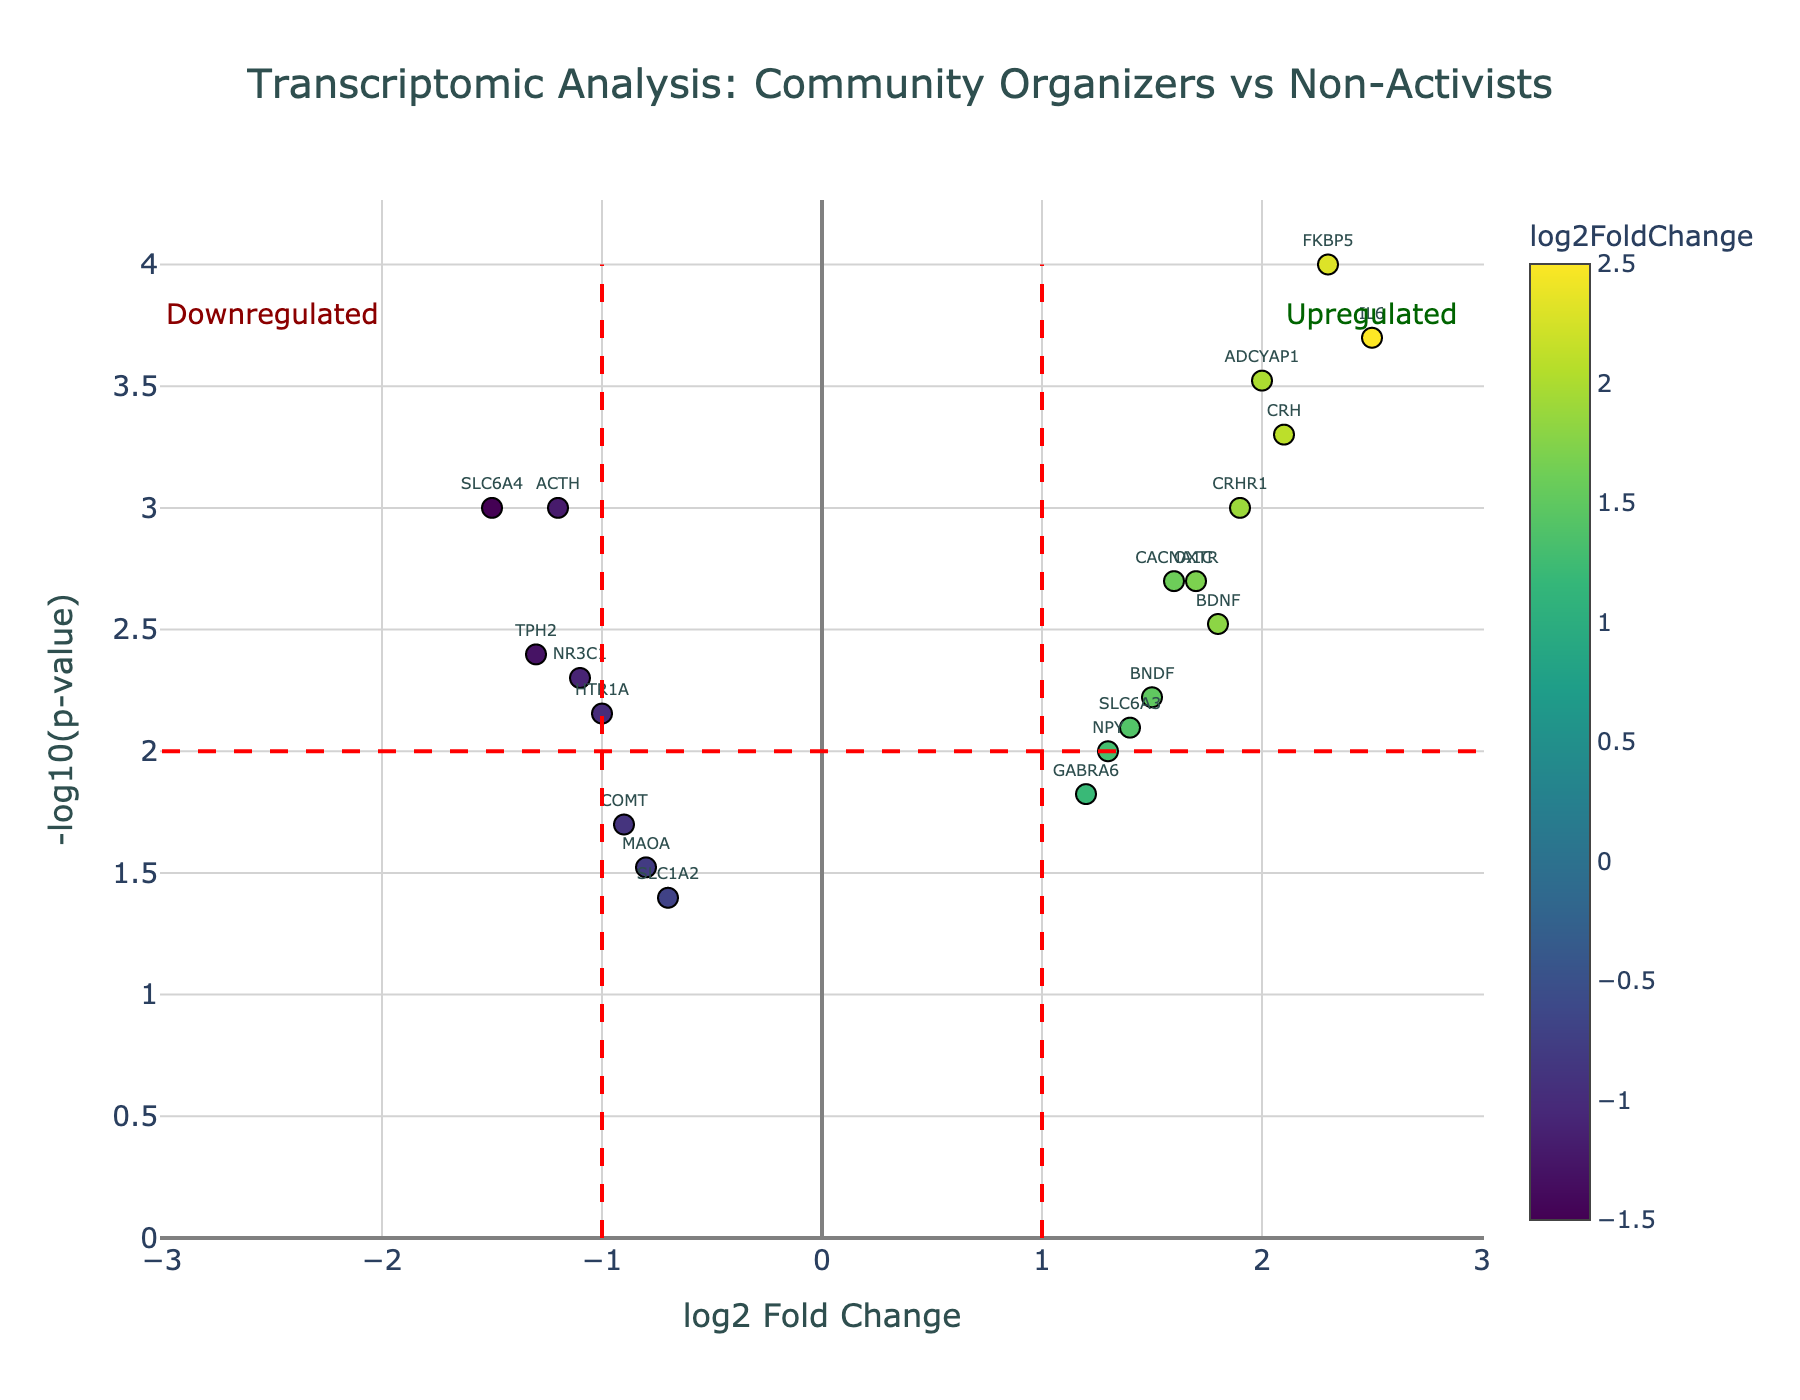What's the title of the figure? The title of the figure is written at the top.
Answer: "Transcriptomic Analysis: Community Organizers vs Non-Activists" How many genes are upregulated with a p-value less than 0.001? Upregulated genes have positive log2 fold change values. Genes with p-values under 0.001 are indicated by a -log10(p-value) greater than 3. There are three such genes: IL6, CRH, and FKBP5.
Answer: 3 Which gene has the highest log2 fold change? The highest log2 fold change is the maximum value on the x-axis. IL6 has the highest log2 fold change value of 2.5.
Answer: IL6 What is the fold change threshold depicted by the vertical lines? The vertical lines are set at log2 fold change values of -1 and 1, marking the threshold for significant fold changes.
Answer: -1 and 1 What is the p-value threshold depicted by the horizontal line? The horizontal line is at -log10(p-value) equal to 2, which equals a p-value of 0.01.
Answer: 0.01 Which gene falls closest to the intersection of the significance thresholds? The intersection is where the vertical lines at -1 and 1 meet the horizontal line at 2. The gene OXTR (log2 fold change of 1.7, p-value 0.002) is closest to this intersection.
Answer: OXTR How many genes have a log2 fold change greater than 1 but less than 2? Genes with log2 fold change in this range are CACNA1C (1.6), OXTR (1.7), BNDF (1.5), CRHR1 (1.9), NPY (1.3), BDNF (1.8), and SLC6A3 (1.4).
Answer: 7 Which gene has the smallest p-value? The smallest p-value is the maximum value on the y-axis. FKBP5 has the smallest p-value of 0.0001.
Answer: FKBP5 Identify one gene with a log2 fold change less than -1.5 The gene SLC6A4 has a log2 fold change of -1.5.
Answer: SLC6A4 What's the combined log2 fold change of ACTH and TPH2? The log2 fold change for ACTH is -1.2, and for TPH2, it's -1.3. Summing these gives -1.2 + (-1.3) = -2.5.
Answer: -2.5 